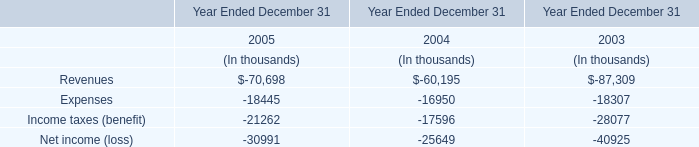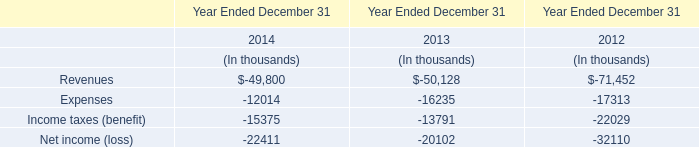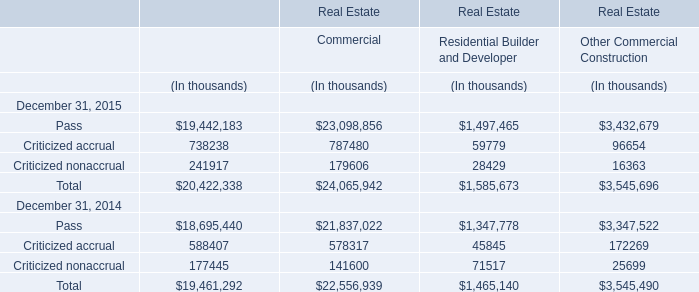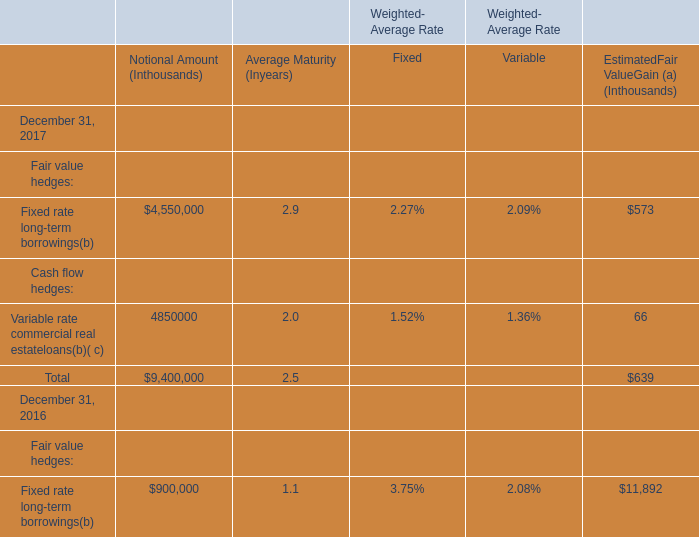At December 31,what year is the Estimated Fair Value Gain for Fair value hedges for Fixed rate long-term borrowings lower? 
Answer: 2017. 